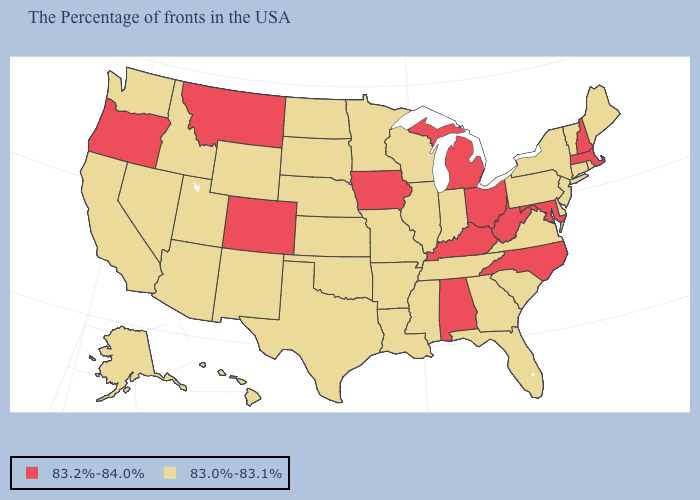Which states have the highest value in the USA?
Give a very brief answer. Massachusetts, New Hampshire, Maryland, North Carolina, West Virginia, Ohio, Michigan, Kentucky, Alabama, Iowa, Colorado, Montana, Oregon. What is the value of Vermont?
Give a very brief answer. 83.0%-83.1%. What is the value of Connecticut?
Be succinct. 83.0%-83.1%. Among the states that border Massachusetts , does New Hampshire have the highest value?
Quick response, please. Yes. What is the highest value in the USA?
Answer briefly. 83.2%-84.0%. What is the value of New York?
Quick response, please. 83.0%-83.1%. Does Minnesota have the highest value in the MidWest?
Be succinct. No. Does Maryland have the highest value in the USA?
Quick response, please. Yes. Name the states that have a value in the range 83.2%-84.0%?
Quick response, please. Massachusetts, New Hampshire, Maryland, North Carolina, West Virginia, Ohio, Michigan, Kentucky, Alabama, Iowa, Colorado, Montana, Oregon. Among the states that border Oklahoma , which have the lowest value?
Keep it brief. Missouri, Arkansas, Kansas, Texas, New Mexico. What is the value of Mississippi?
Write a very short answer. 83.0%-83.1%. What is the value of Connecticut?
Concise answer only. 83.0%-83.1%. Among the states that border Oklahoma , which have the lowest value?
Be succinct. Missouri, Arkansas, Kansas, Texas, New Mexico. Does Louisiana have the same value as Nebraska?
Short answer required. Yes. What is the value of Oregon?
Answer briefly. 83.2%-84.0%. 